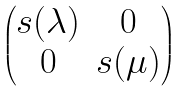Convert formula to latex. <formula><loc_0><loc_0><loc_500><loc_500>\begin{pmatrix} s ( \lambda ) & 0 \\ 0 & s ( \mu ) \end{pmatrix}</formula> 